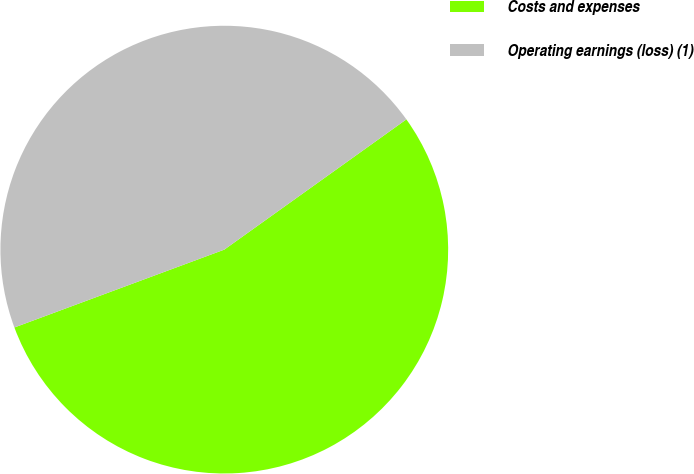Convert chart to OTSL. <chart><loc_0><loc_0><loc_500><loc_500><pie_chart><fcel>Costs and expenses<fcel>Operating earnings (loss) (1)<nl><fcel>54.23%<fcel>45.77%<nl></chart> 